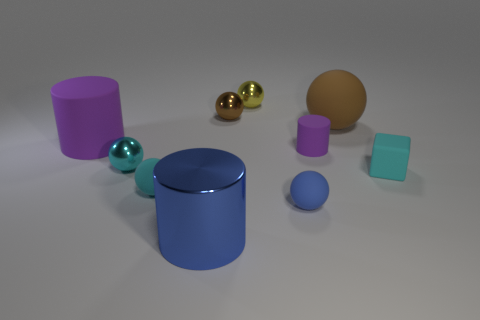Subtract all purple matte cylinders. How many cylinders are left? 1 Subtract 1 cylinders. How many cylinders are left? 2 Subtract all gray spheres. How many purple cylinders are left? 2 Subtract all blue spheres. How many spheres are left? 5 Add 8 large blue metallic blocks. How many large blue metallic blocks exist? 8 Subtract 0 green cubes. How many objects are left? 10 Subtract all spheres. How many objects are left? 4 Subtract all yellow spheres. Subtract all cyan cubes. How many spheres are left? 5 Subtract all small brown spheres. Subtract all tiny blue objects. How many objects are left? 8 Add 7 cyan metallic balls. How many cyan metallic balls are left? 8 